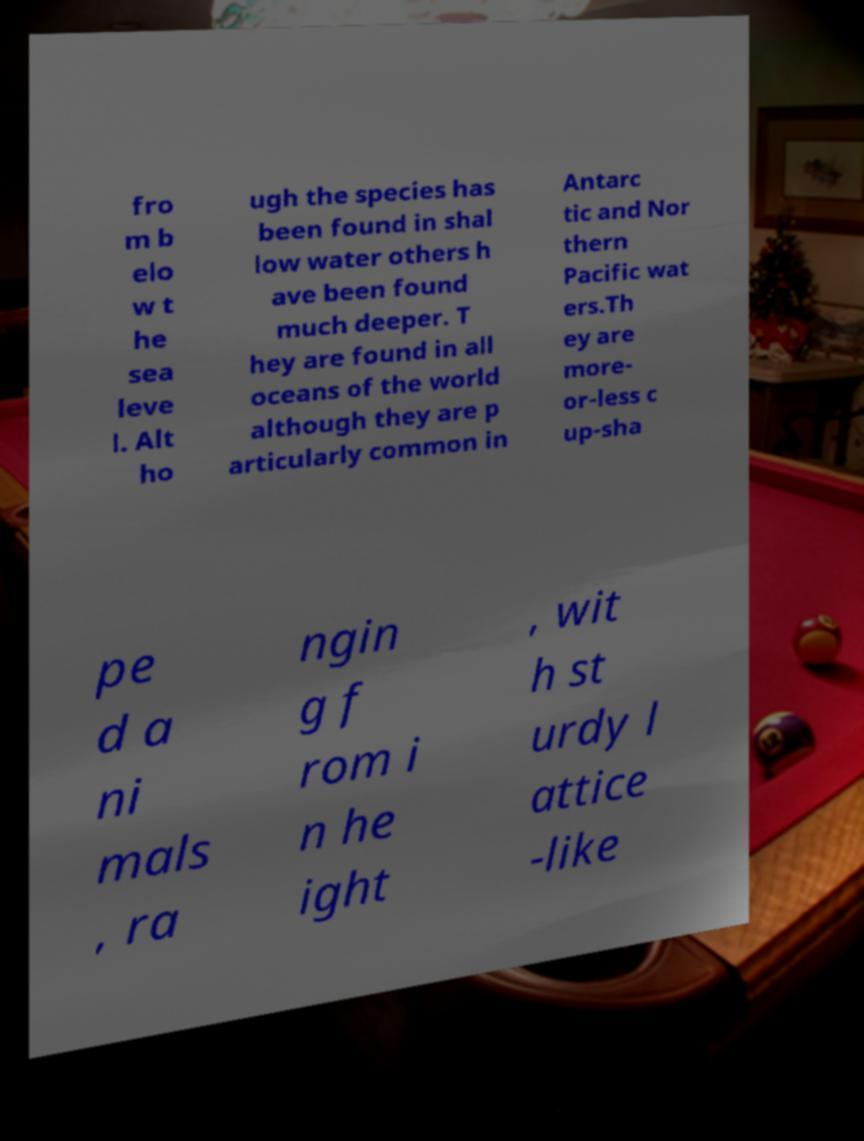Could you assist in decoding the text presented in this image and type it out clearly? fro m b elo w t he sea leve l. Alt ho ugh the species has been found in shal low water others h ave been found much deeper. T hey are found in all oceans of the world although they are p articularly common in Antarc tic and Nor thern Pacific wat ers.Th ey are more- or-less c up-sha pe d a ni mals , ra ngin g f rom i n he ight , wit h st urdy l attice -like 